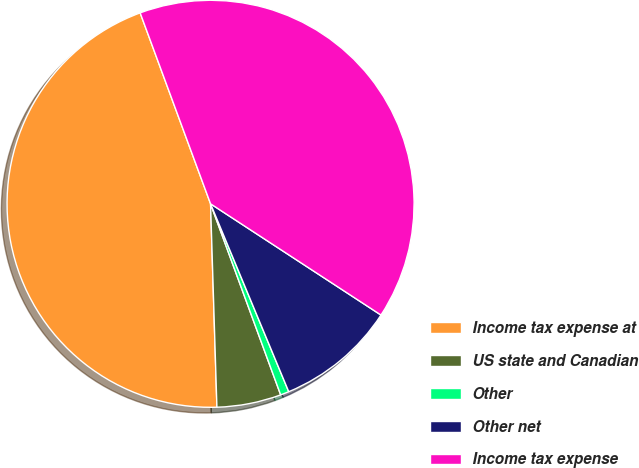Convert chart. <chart><loc_0><loc_0><loc_500><loc_500><pie_chart><fcel>Income tax expense at<fcel>US state and Canadian<fcel>Other<fcel>Other net<fcel>Income tax expense<nl><fcel>44.88%<fcel>5.1%<fcel>0.68%<fcel>9.52%<fcel>39.83%<nl></chart> 